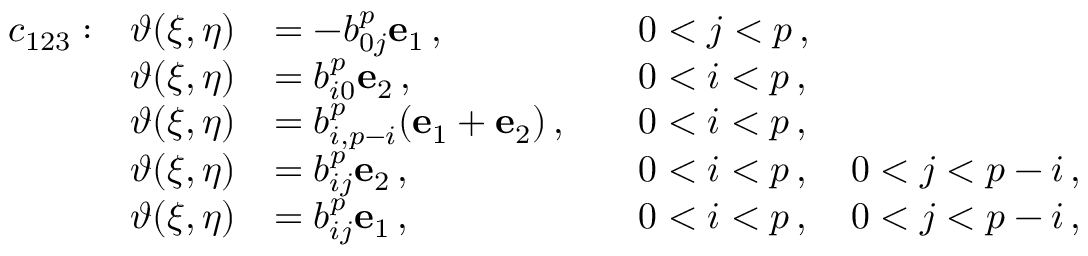Convert formula to latex. <formula><loc_0><loc_0><loc_500><loc_500>\begin{array} { r l r l r l } & { c _ { 1 2 3 } \colon } & { \vartheta ( \xi , \eta ) } & { = - b _ { 0 j } ^ { p } e _ { 1 } \, , } & & { 0 < j < p \, , } \\ & { \vartheta ( \xi , \eta ) } & { = b _ { i 0 } ^ { p } e _ { 2 } \, , } & & { 0 < i < p \, , } \\ & { \vartheta ( \xi , \eta ) } & { = b _ { i , p - i } ^ { p } ( e _ { 1 } + e _ { 2 } ) \, , } & & { 0 < i < p \, , } \\ & { \vartheta ( \xi , \eta ) } & { = b _ { i j } ^ { p } e _ { 2 } \, , } & & { 0 < i < p \, , \quad 0 < j < p - i \, , } \\ & { \vartheta ( \xi , \eta ) } & { = b _ { i j } ^ { p } e _ { 1 } \, , } & & { 0 < i < p \, , \quad 0 < j < p - i \, , } \end{array}</formula> 